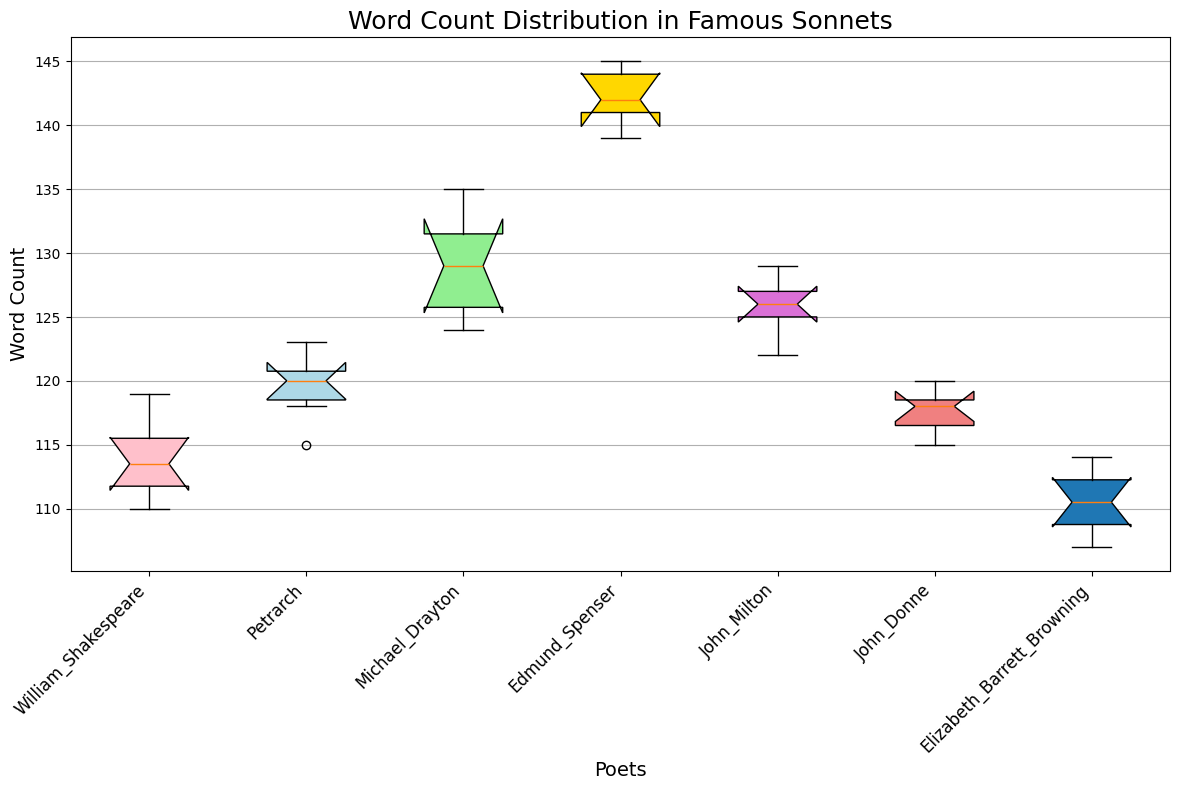What is the median word count for William Shakespeare's sonnets? The median can be found at the center of Shakespeare's box plot. The middle line within the box represents the median word count.
Answer: 113 Which poet has the highest upper whisker in the box plot? The upper whisker is the highest line that extends from the top of each box. By examining the whiskers, Edmund Spenser has the highest upper whisker.
Answer: Edmund Spenser Which poet has the smallest interquartile range (IQR) for their sonnet word counts? The interquartile range is represented by the height of the box. By comparing the boxes, Elizabeth Barrett Browning has the smallest IQR.
Answer: Elizabeth Barrett Browning How does the word count distribution for Michael Drayton compare to that of John Donne? Michael Drayton's box is higher with a larger IQR, indicating a higher and more variable word count compared to John Donne's.
Answer: Michael Drayton has a higher and more variable word count distribution Summarize the word count distribution range for Petrarch's sonnets using the visual features of the box plot. The range is from the bottom whisker to the top whisker of Petrarch's box plot. Petrarch's sonnets have lower and upper whiskers, suggesting the range of word counts.
Answer: Approximately 115 to 123 Do any poets have outliers in their word count distribution? If so, who are they? Outliers would be marked as individual points beyond the whiskers. By examining the figure, no outliers are present for any poet.
Answer: No outliers Which poet's sonnets have the highest median word count? The median is the central line in each box. Comparing these lines, Edmund Spenser's sonnets have the highest median word count.
Answer: Edmund Spenser Between John Milton and John Donne, who has a greater variability in sonnet word counts? Variability is shown by the length of the box. John Milton's box is taller, indicating more variability than John Donne's.
Answer: John Milton How does the maximum word count for Elizabeth Barrett Browning's sonnets compare to that of William Shakespeare's? The maximum is denoted by the top whisker. Comparing these whiskers, William Shakespeare's sonnets have a higher maximum word count than Elizabeth Barrett Browning's.
Answer: William Shakespeare What is the notch feature's significance in the box plot, and how does it help compare the distributions of word counts? The notch represents a confidence interval for the median. Non-overlapping notches between two boxes indicates that there is a statistical difference between their medians, providing a visual means to compare medians of different poets.
Answer: Confidence intervals for comparing medians 